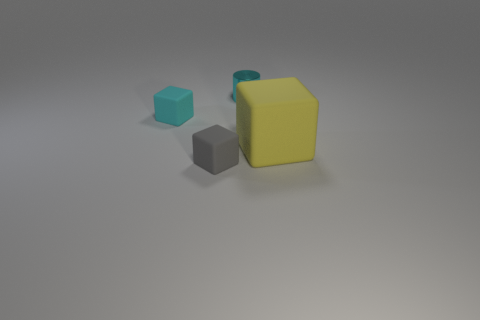Add 4 tiny cyan cylinders. How many objects exist? 8 Subtract all cubes. How many objects are left? 1 Subtract all tiny cyan matte objects. Subtract all large rubber things. How many objects are left? 2 Add 1 tiny gray matte things. How many tiny gray matte things are left? 2 Add 2 large blue metallic cubes. How many large blue metallic cubes exist? 2 Subtract 0 green blocks. How many objects are left? 4 